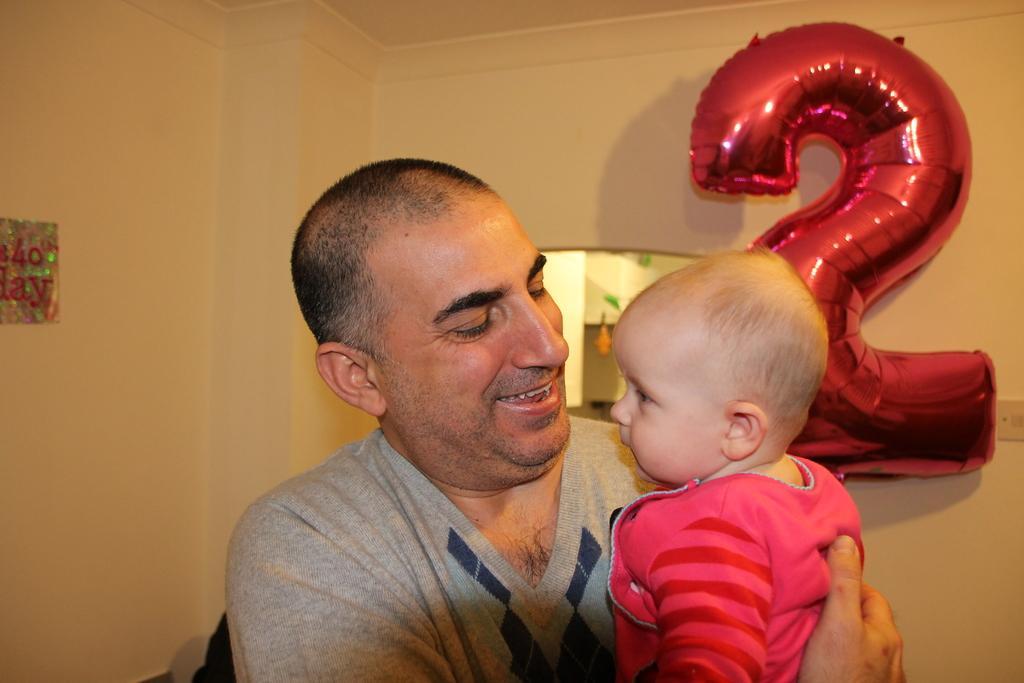Can you describe this image briefly? In this image, I can see the man standing and smiling. He is carrying a baby. On the right side of the image, It looks like a helium balloon. On the left side of the image, I can see a poster, which is attached to the wall. 